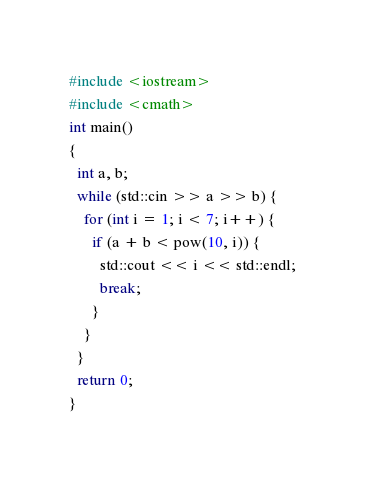<code> <loc_0><loc_0><loc_500><loc_500><_C++_>#include <iostream>
#include <cmath>
int main()
{
  int a, b;
  while (std::cin >> a >> b) {
    for (int i = 1; i < 7; i++) {
      if (a + b < pow(10, i)) {
        std::cout << i << std::endl;
        break;
      }
    }
  }
  return 0;
}</code> 